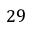Convert formula to latex. <formula><loc_0><loc_0><loc_500><loc_500>2 9</formula> 